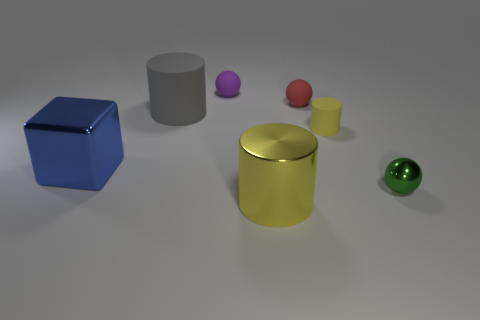What number of big blue objects are to the right of the rubber cylinder that is to the right of the red object? 0 